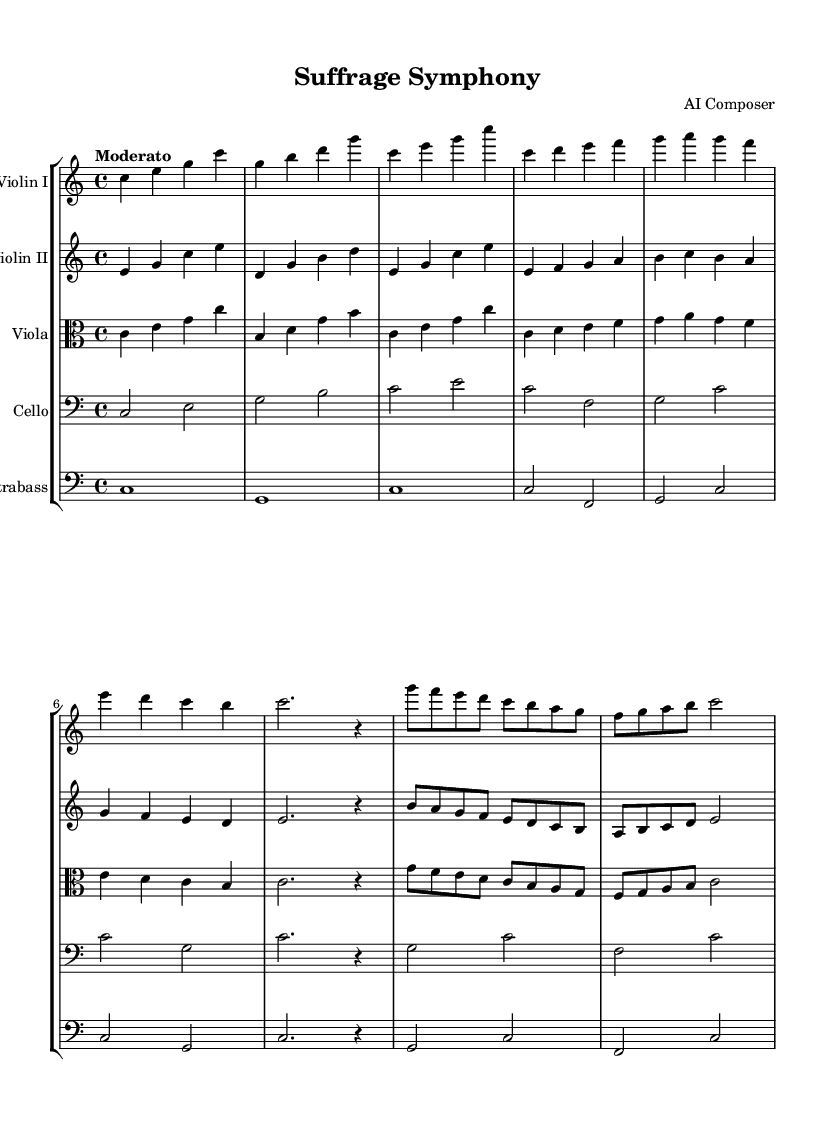What is the key signature of this music? The key signature is indicated at the beginning of the score. The absence of sharps or flats shows that it is in C major.
Answer: C major What is the time signature of this composition? The time signature is noted at the start of the score, appears as a fraction. This music has a time signature of 4 over 4.
Answer: 4/4 What is the tempo marking for this piece? The tempo is indicated at the top of the score, stating "Moderato," which means a moderate pace.
Answer: Moderato How many main themes are presented in the composition? By observing the structure, one can identify two distinct themes labeled Theme A and Theme B in the notation.
Answer: Two What is the lowest instrument in this score? The instruments are arranged by pitch, and by analyzing the parts, the contrabass is the lowest in pitch on the staff.
Answer: Contrabass What is the melodic range of the violin I part? By examining the notes written for violin I, we see that it spans from C to G, defining its range within that octave.
Answer: C to G Which instrument plays the introduction? The introduction is played by all string instruments harmoniously, visible in their respective parts at the start of the score.
Answer: All instruments 